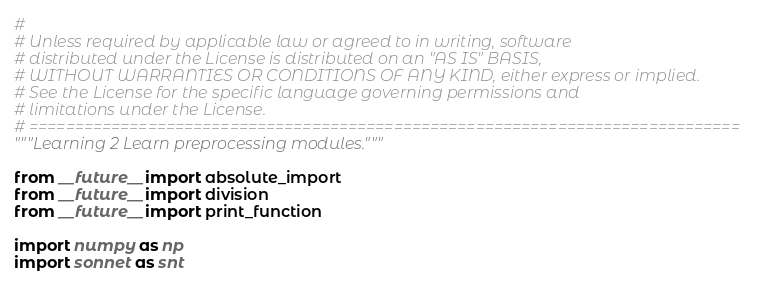Convert code to text. <code><loc_0><loc_0><loc_500><loc_500><_Python_>#
# Unless required by applicable law or agreed to in writing, software
# distributed under the License is distributed on an "AS IS" BASIS,
# WITHOUT WARRANTIES OR CONDITIONS OF ANY KIND, either express or implied.
# See the License for the specific language governing permissions and
# limitations under the License.
# ==============================================================================
"""Learning 2 Learn preprocessing modules."""

from __future__ import absolute_import
from __future__ import division
from __future__ import print_function

import numpy as np
import sonnet as snt</code> 